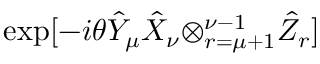<formula> <loc_0><loc_0><loc_500><loc_500>\exp [ - i \theta \hat { Y } _ { \mu } \hat { X } _ { \nu } { \otimes _ { r = \mu + 1 } ^ { \nu - 1 } } \hat { Z } _ { r } ]</formula> 